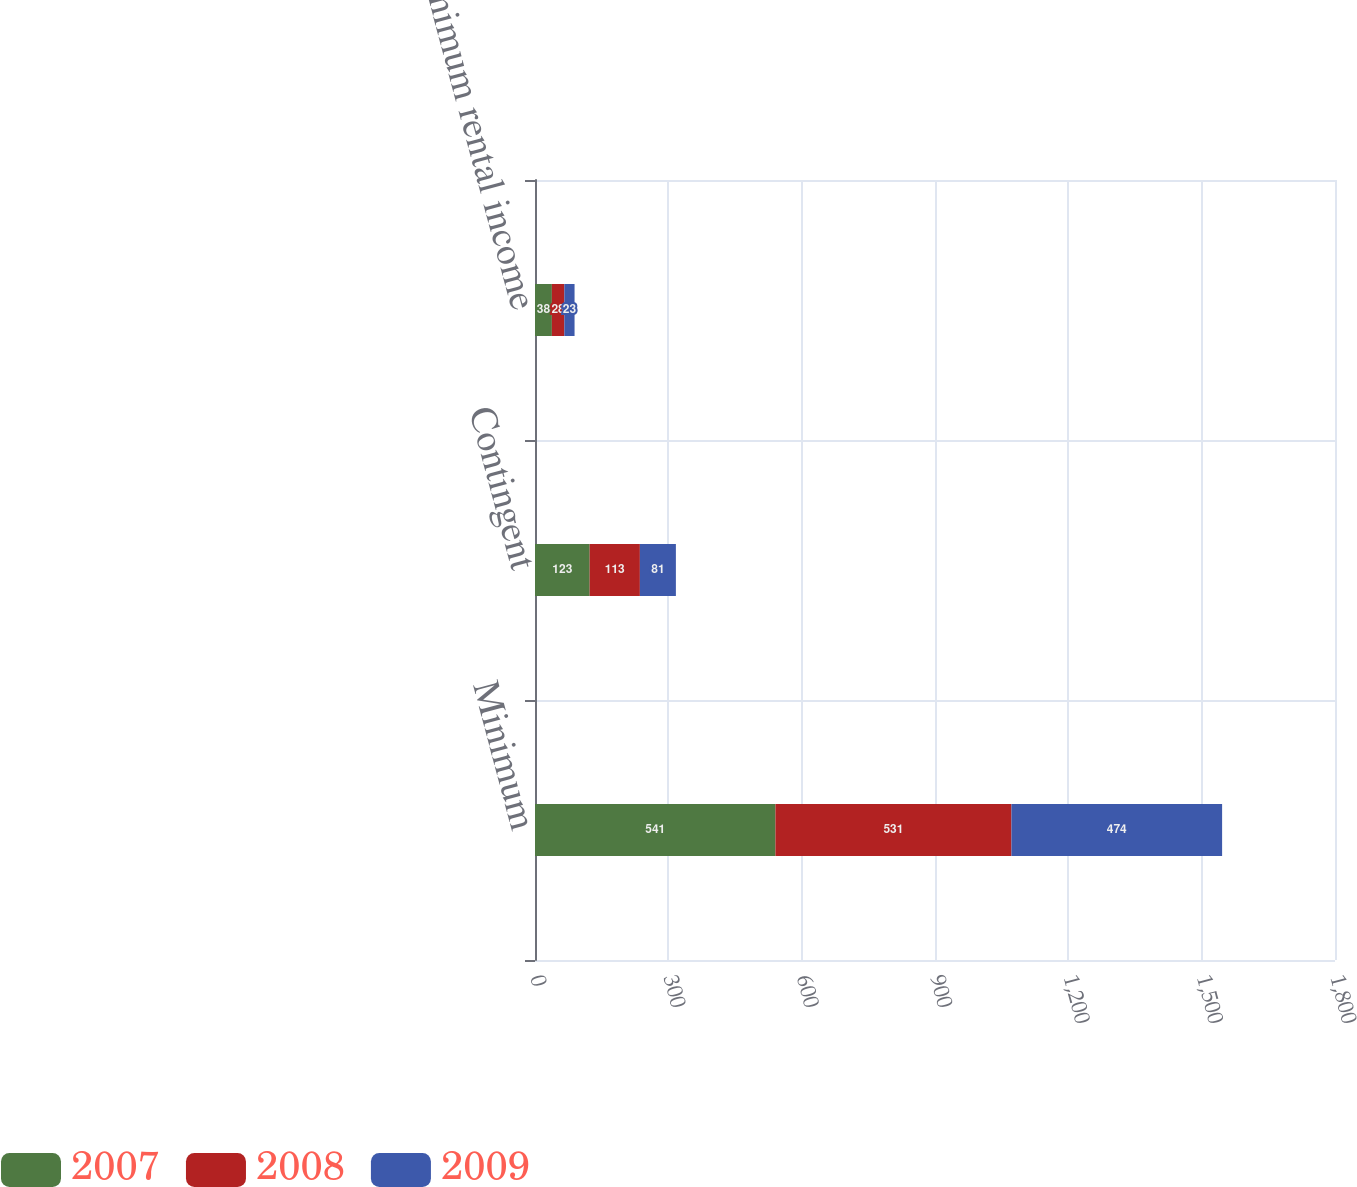<chart> <loc_0><loc_0><loc_500><loc_500><stacked_bar_chart><ecel><fcel>Minimum<fcel>Contingent<fcel>Minimum rental income<nl><fcel>2007<fcel>541<fcel>123<fcel>38<nl><fcel>2008<fcel>531<fcel>113<fcel>28<nl><fcel>2009<fcel>474<fcel>81<fcel>23<nl></chart> 